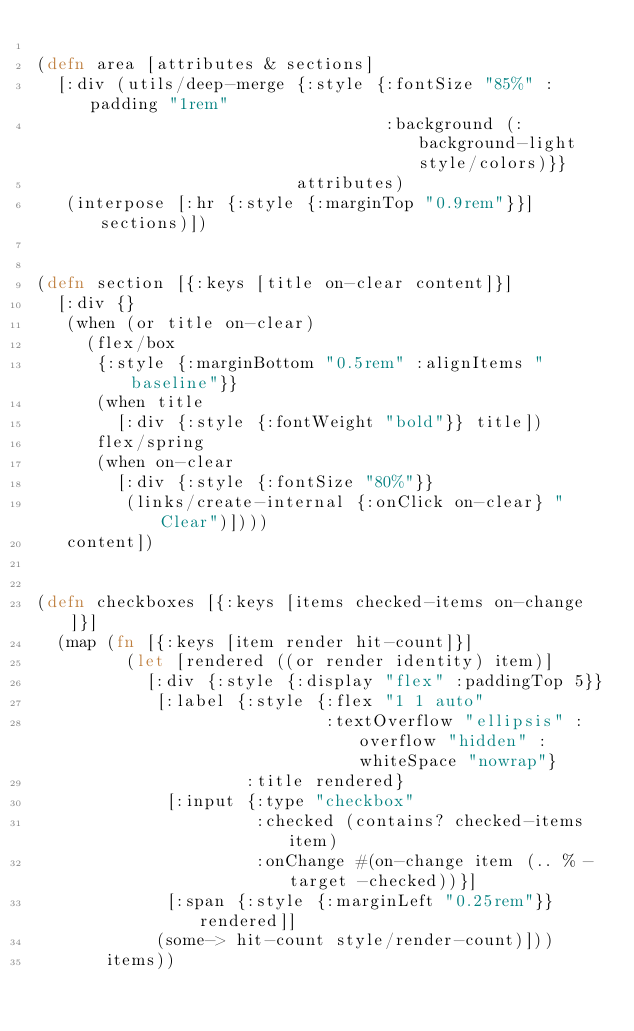<code> <loc_0><loc_0><loc_500><loc_500><_Clojure_>
(defn area [attributes & sections]
  [:div (utils/deep-merge {:style {:fontSize "85%" :padding "1rem"
                                   :background (:background-light style/colors)}}
                          attributes)
   (interpose [:hr {:style {:marginTop "0.9rem"}}] sections)])


(defn section [{:keys [title on-clear content]}]
  [:div {}
   (when (or title on-clear)
     (flex/box
      {:style {:marginBottom "0.5rem" :alignItems "baseline"}}
      (when title
        [:div {:style {:fontWeight "bold"}} title])
      flex/spring
      (when on-clear
        [:div {:style {:fontSize "80%"}}
         (links/create-internal {:onClick on-clear} "Clear")])))
   content])


(defn checkboxes [{:keys [items checked-items on-change]}]
  (map (fn [{:keys [item render hit-count]}]
         (let [rendered ((or render identity) item)]
           [:div {:style {:display "flex" :paddingTop 5}}
            [:label {:style {:flex "1 1 auto"
                             :textOverflow "ellipsis" :overflow "hidden" :whiteSpace "nowrap"}
                     :title rendered}
             [:input {:type "checkbox"
                      :checked (contains? checked-items item)
                      :onChange #(on-change item (.. % -target -checked))}]
             [:span {:style {:marginLeft "0.25rem"}} rendered]]
            (some-> hit-count style/render-count)]))
       items))
</code> 